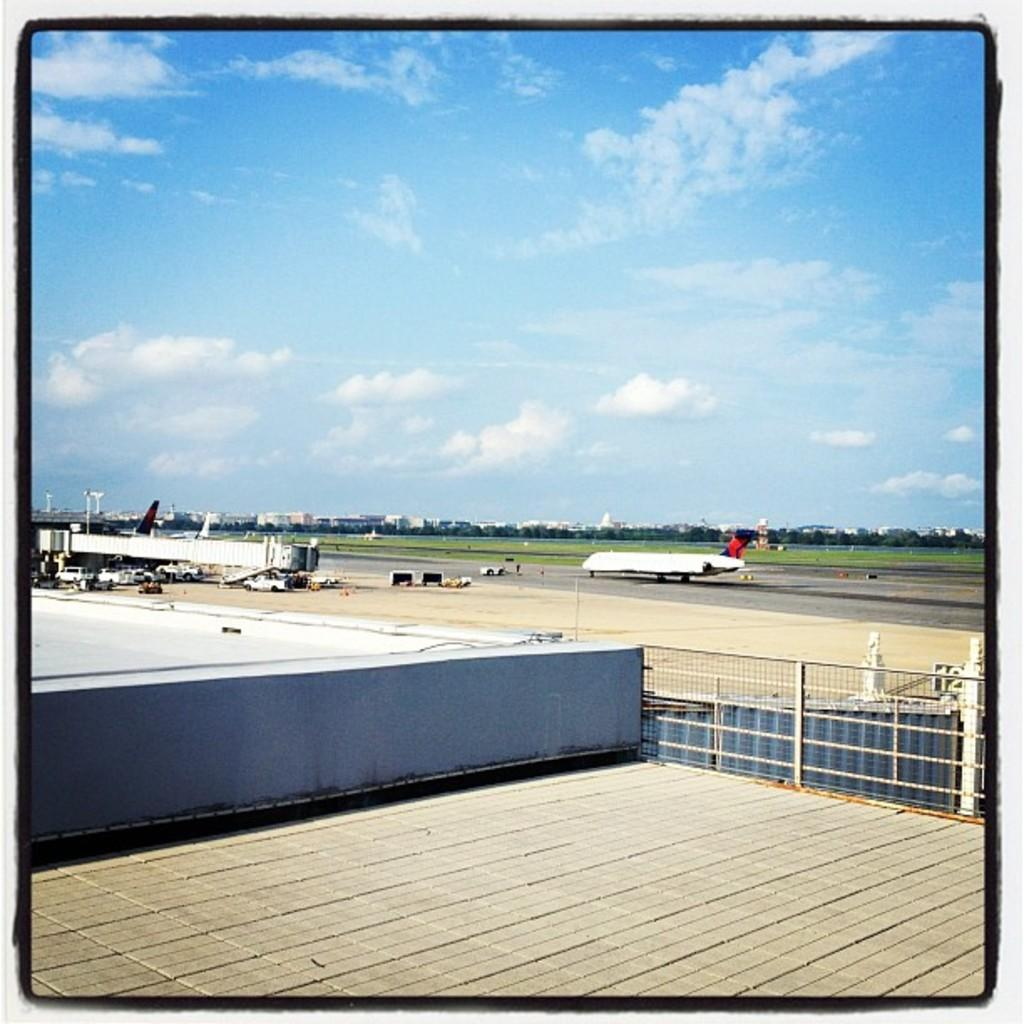What type of barrier can be seen in the image? There is a fence in the image. What object is present for holding or storing items? There is a container in the image. What can be seen in the distance in the image? Vehicles, an airplane on the runway, buildings, and trees are visible in the background of the image. What type of can is depicted in the image? There is no can present in the image. What riddle can be solved by looking at the image? There is no riddle associated with the image. 